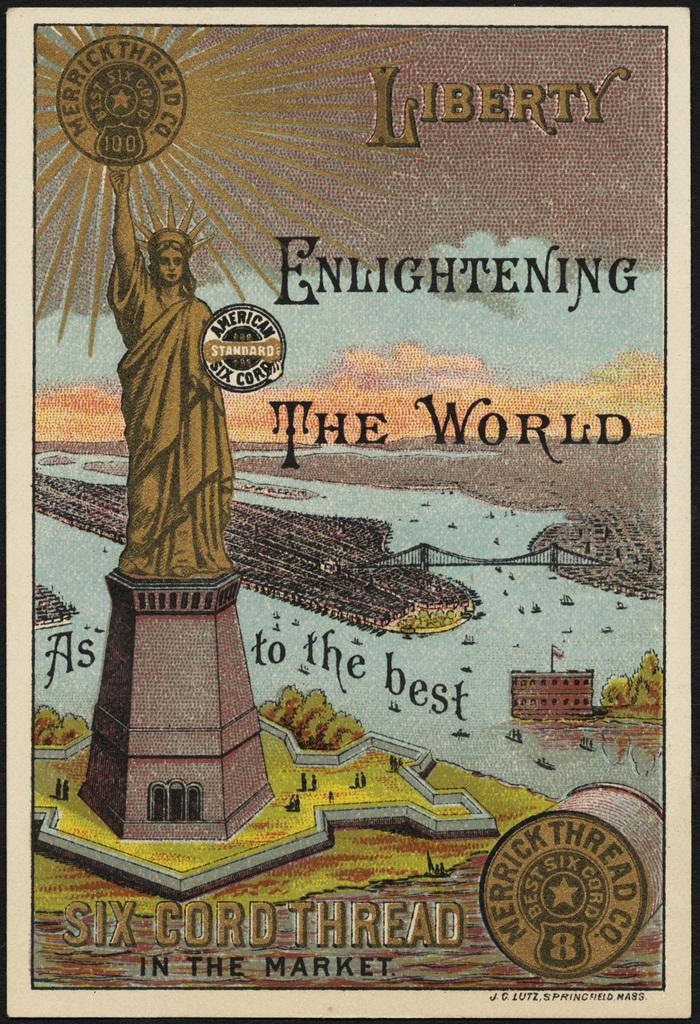Who made this ad or poster?
Your answer should be compact. Merrick thread co. What is enlightening the world?
Keep it short and to the point. Liberty. 